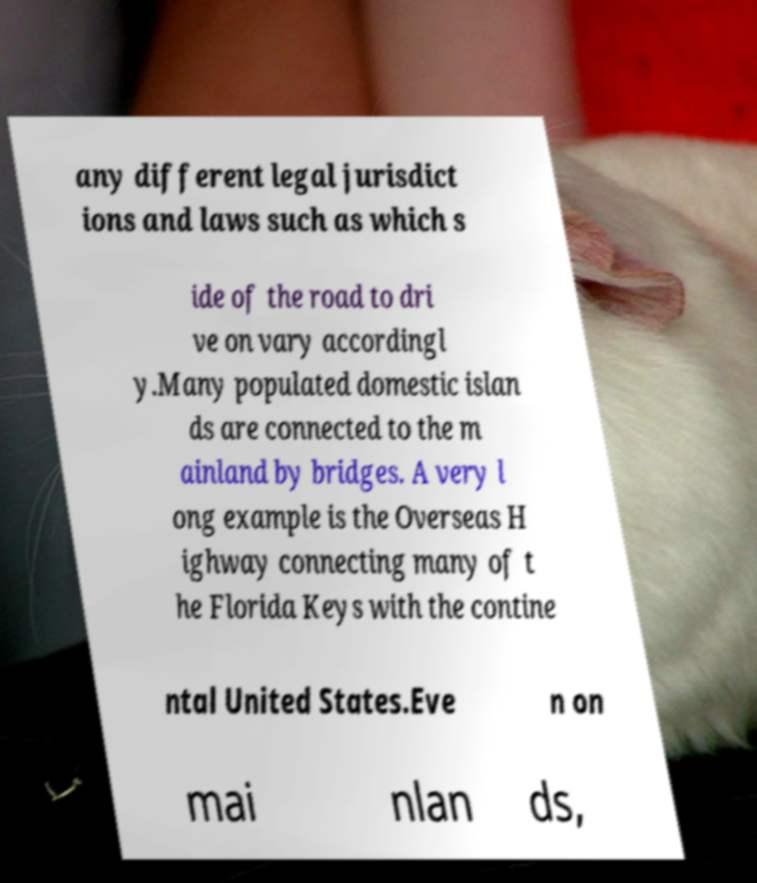Could you assist in decoding the text presented in this image and type it out clearly? any different legal jurisdict ions and laws such as which s ide of the road to dri ve on vary accordingl y.Many populated domestic islan ds are connected to the m ainland by bridges. A very l ong example is the Overseas H ighway connecting many of t he Florida Keys with the contine ntal United States.Eve n on mai nlan ds, 